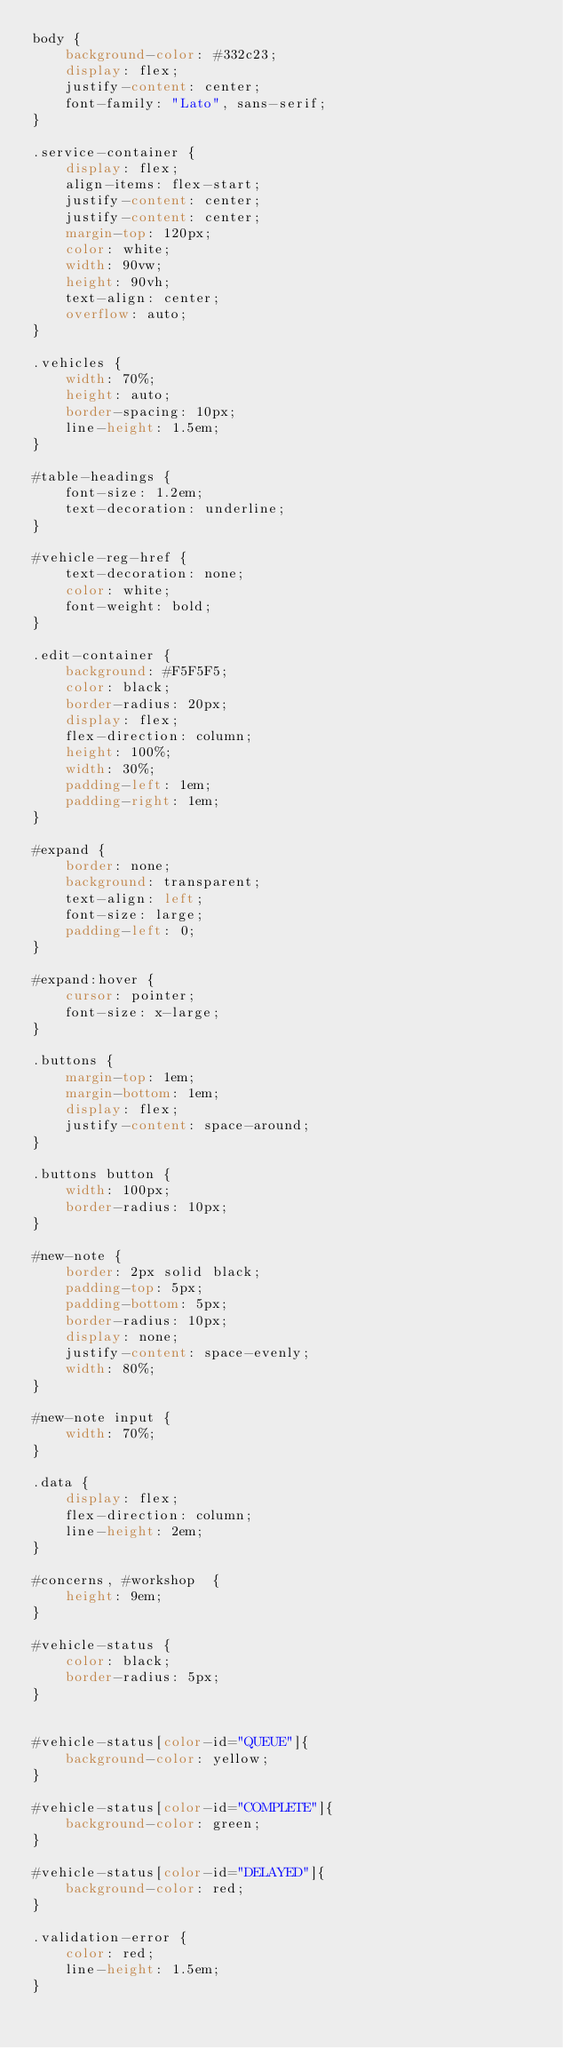<code> <loc_0><loc_0><loc_500><loc_500><_CSS_>body {
    background-color: #332c23;
    display: flex;
    justify-content: center;
    font-family: "Lato", sans-serif;
}

.service-container {
    display: flex;
    align-items: flex-start;
    justify-content: center;
    justify-content: center;
    margin-top: 120px;
    color: white;
    width: 90vw;
    height: 90vh;
    text-align: center;
    overflow: auto;
}

.vehicles {
    width: 70%;
    height: auto;
    border-spacing: 10px;
    line-height: 1.5em;
}

#table-headings {
    font-size: 1.2em;
    text-decoration: underline;
}

#vehicle-reg-href {
    text-decoration: none;
    color: white;
    font-weight: bold;
}

.edit-container {
    background: #F5F5F5;
    color: black;
    border-radius: 20px;
    display: flex;
    flex-direction: column;
    height: 100%;
    width: 30%;
    padding-left: 1em;
    padding-right: 1em;
}

#expand {
    border: none;
    background: transparent;
    text-align: left;
    font-size: large;
    padding-left: 0;
}

#expand:hover {
    cursor: pointer;
    font-size: x-large;
}

.buttons {
    margin-top: 1em;
    margin-bottom: 1em;
    display: flex;
    justify-content: space-around;
}

.buttons button {
    width: 100px;
    border-radius: 10px;
}

#new-note {
    border: 2px solid black;
    padding-top: 5px;
    padding-bottom: 5px;
    border-radius: 10px;
    display: none;
    justify-content: space-evenly;
    width: 80%;
}

#new-note input {
    width: 70%;
}

.data {
    display: flex;
    flex-direction: column;
    line-height: 2em;
}

#concerns, #workshop  {
    height: 9em;
}

#vehicle-status {
    color: black;
    border-radius: 5px;
}


#vehicle-status[color-id="QUEUE"]{
    background-color: yellow;
}

#vehicle-status[color-id="COMPLETE"]{
    background-color: green;
}

#vehicle-status[color-id="DELAYED"]{
    background-color: red;
}

.validation-error {
    color: red;
    line-height: 1.5em;
}

</code> 